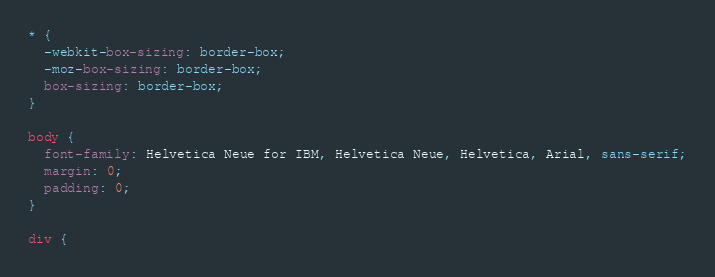<code> <loc_0><loc_0><loc_500><loc_500><_CSS_>* {
  -webkit-box-sizing: border-box;
  -moz-box-sizing: border-box;
  box-sizing: border-box;
}

body {
  font-family: Helvetica Neue for IBM, Helvetica Neue, Helvetica, Arial, sans-serif;
  margin: 0;
  padding: 0;
}

div {</code> 